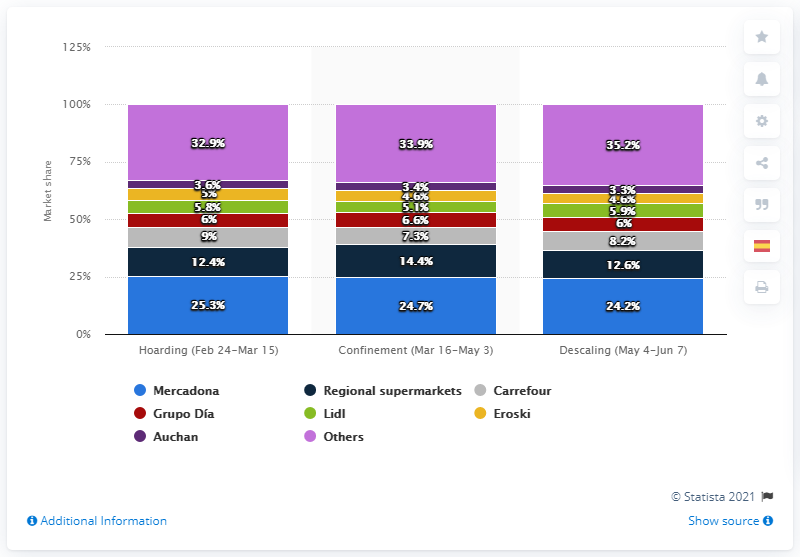Identify some key points in this picture. Mercadona was the preferred supermarket chain of a significant portion of the Spanish population. 